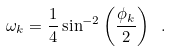Convert formula to latex. <formula><loc_0><loc_0><loc_500><loc_500>\omega _ { k } = \frac { 1 } { 4 } \sin ^ { - 2 } \left ( \frac { \phi _ { k } } { 2 } \right ) \ .</formula> 